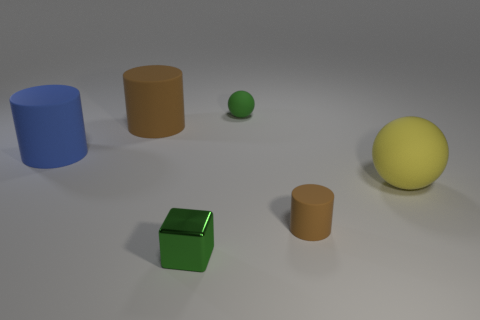Subtract all large cylinders. How many cylinders are left? 1 Subtract 1 cylinders. How many cylinders are left? 2 Add 3 small brown matte cylinders. How many objects exist? 9 Subtract all cubes. How many objects are left? 5 Add 3 yellow spheres. How many yellow spheres are left? 4 Add 1 large shiny cylinders. How many large shiny cylinders exist? 1 Subtract 1 green blocks. How many objects are left? 5 Subtract all small green cubes. Subtract all small brown matte cylinders. How many objects are left? 4 